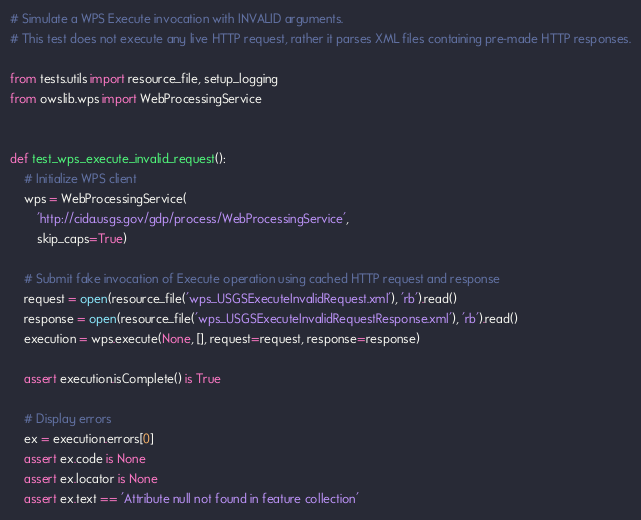<code> <loc_0><loc_0><loc_500><loc_500><_Python_># Simulate a WPS Execute invocation with INVALID arguments.
# This test does not execute any live HTTP request, rather it parses XML files containing pre-made HTTP responses.

from tests.utils import resource_file, setup_logging
from owslib.wps import WebProcessingService


def test_wps_execute_invalid_request():
    # Initialize WPS client
    wps = WebProcessingService(
        'http://cida.usgs.gov/gdp/process/WebProcessingService',
        skip_caps=True)

    # Submit fake invocation of Execute operation using cached HTTP request and response
    request = open(resource_file('wps_USGSExecuteInvalidRequest.xml'), 'rb').read()
    response = open(resource_file('wps_USGSExecuteInvalidRequestResponse.xml'), 'rb').read()
    execution = wps.execute(None, [], request=request, response=response)

    assert execution.isComplete() is True

    # Display errors
    ex = execution.errors[0]
    assert ex.code is None
    assert ex.locator is None
    assert ex.text == 'Attribute null not found in feature collection'
</code> 